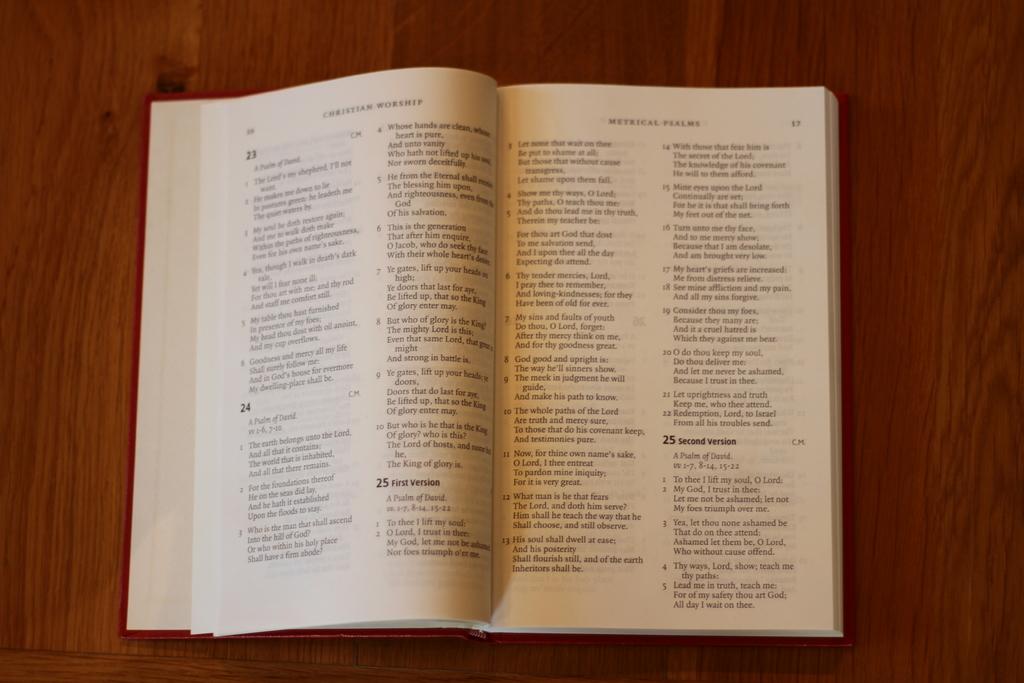How many versions of section 25 are shown on these pages?
Your response must be concise. 2. What is the title of the page on the right?
Your answer should be very brief. Metrical psalms. 